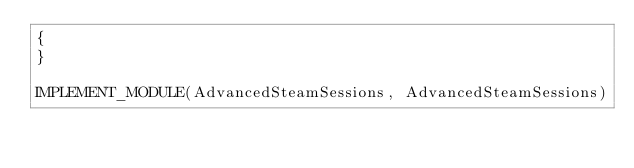<code> <loc_0><loc_0><loc_500><loc_500><_C++_>{
}
 
IMPLEMENT_MODULE(AdvancedSteamSessions, AdvancedSteamSessions)</code> 